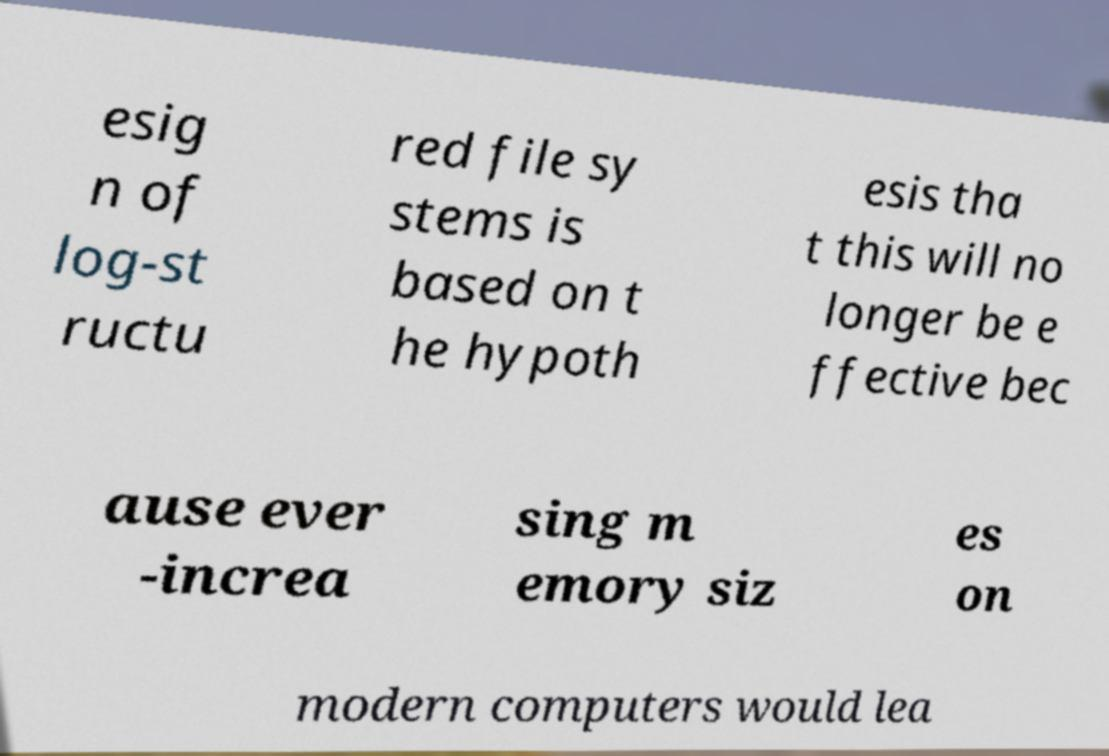Please identify and transcribe the text found in this image. esig n of log-st ructu red file sy stems is based on t he hypoth esis tha t this will no longer be e ffective bec ause ever -increa sing m emory siz es on modern computers would lea 